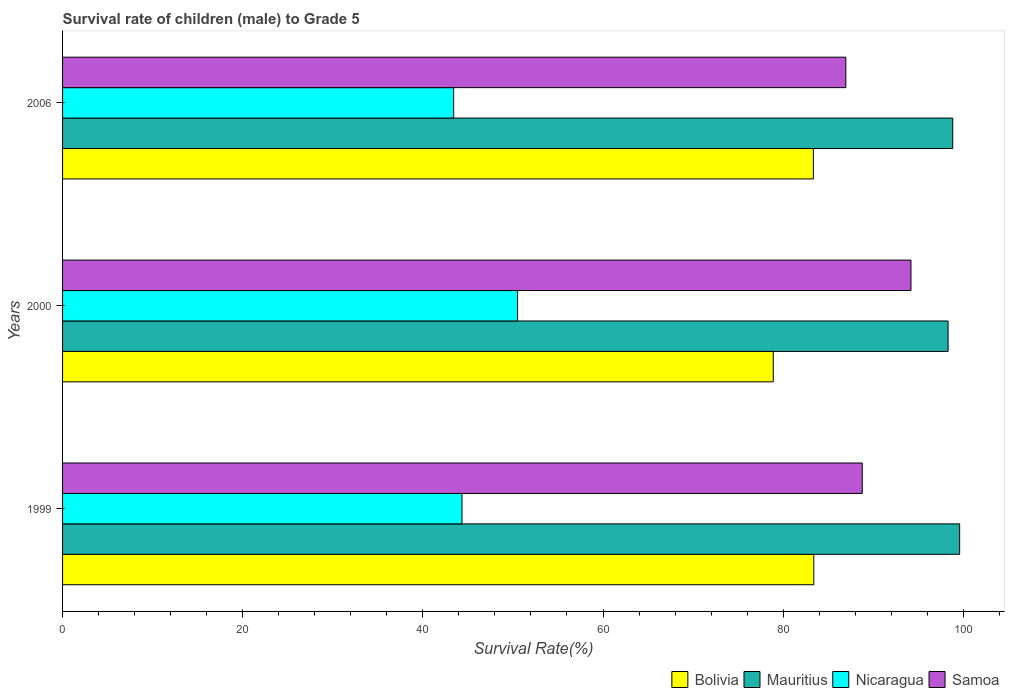How many bars are there on the 1st tick from the top?
Give a very brief answer. 4. In how many cases, is the number of bars for a given year not equal to the number of legend labels?
Provide a short and direct response. 0. What is the survival rate of male children to grade 5 in Samoa in 2006?
Make the answer very short. 86.96. Across all years, what is the maximum survival rate of male children to grade 5 in Samoa?
Your response must be concise. 94.19. Across all years, what is the minimum survival rate of male children to grade 5 in Samoa?
Offer a terse response. 86.96. In which year was the survival rate of male children to grade 5 in Samoa maximum?
Your answer should be very brief. 2000. What is the total survival rate of male children to grade 5 in Mauritius in the graph?
Keep it short and to the point. 296.73. What is the difference between the survival rate of male children to grade 5 in Bolivia in 1999 and that in 2000?
Provide a succinct answer. 4.5. What is the difference between the survival rate of male children to grade 5 in Nicaragua in 2000 and the survival rate of male children to grade 5 in Samoa in 1999?
Your response must be concise. -38.27. What is the average survival rate of male children to grade 5 in Samoa per year?
Ensure brevity in your answer.  89.98. In the year 2000, what is the difference between the survival rate of male children to grade 5 in Nicaragua and survival rate of male children to grade 5 in Samoa?
Give a very brief answer. -43.67. In how many years, is the survival rate of male children to grade 5 in Samoa greater than 28 %?
Your response must be concise. 3. What is the ratio of the survival rate of male children to grade 5 in Mauritius in 1999 to that in 2000?
Ensure brevity in your answer.  1.01. Is the difference between the survival rate of male children to grade 5 in Nicaragua in 2000 and 2006 greater than the difference between the survival rate of male children to grade 5 in Samoa in 2000 and 2006?
Offer a terse response. No. What is the difference between the highest and the second highest survival rate of male children to grade 5 in Samoa?
Provide a succinct answer. 5.41. What is the difference between the highest and the lowest survival rate of male children to grade 5 in Bolivia?
Make the answer very short. 4.5. In how many years, is the survival rate of male children to grade 5 in Nicaragua greater than the average survival rate of male children to grade 5 in Nicaragua taken over all years?
Your answer should be very brief. 1. Is it the case that in every year, the sum of the survival rate of male children to grade 5 in Nicaragua and survival rate of male children to grade 5 in Bolivia is greater than the sum of survival rate of male children to grade 5 in Samoa and survival rate of male children to grade 5 in Mauritius?
Offer a very short reply. No. What does the 4th bar from the top in 1999 represents?
Ensure brevity in your answer.  Bolivia. What does the 4th bar from the bottom in 1999 represents?
Provide a short and direct response. Samoa. Are all the bars in the graph horizontal?
Your answer should be compact. Yes. What is the difference between two consecutive major ticks on the X-axis?
Your answer should be very brief. 20. Does the graph contain any zero values?
Your answer should be compact. No. How are the legend labels stacked?
Make the answer very short. Horizontal. What is the title of the graph?
Offer a terse response. Survival rate of children (male) to Grade 5. What is the label or title of the X-axis?
Offer a terse response. Survival Rate(%). What is the Survival Rate(%) in Bolivia in 1999?
Offer a very short reply. 83.4. What is the Survival Rate(%) of Mauritius in 1999?
Ensure brevity in your answer.  99.59. What is the Survival Rate(%) of Nicaragua in 1999?
Your answer should be very brief. 44.34. What is the Survival Rate(%) of Samoa in 1999?
Give a very brief answer. 88.78. What is the Survival Rate(%) of Bolivia in 2000?
Provide a short and direct response. 78.9. What is the Survival Rate(%) in Mauritius in 2000?
Give a very brief answer. 98.31. What is the Survival Rate(%) in Nicaragua in 2000?
Provide a succinct answer. 50.51. What is the Survival Rate(%) in Samoa in 2000?
Your answer should be compact. 94.19. What is the Survival Rate(%) in Bolivia in 2006?
Offer a terse response. 83.35. What is the Survival Rate(%) in Mauritius in 2006?
Make the answer very short. 98.82. What is the Survival Rate(%) in Nicaragua in 2006?
Keep it short and to the point. 43.42. What is the Survival Rate(%) in Samoa in 2006?
Keep it short and to the point. 86.96. Across all years, what is the maximum Survival Rate(%) of Bolivia?
Your response must be concise. 83.4. Across all years, what is the maximum Survival Rate(%) in Mauritius?
Offer a very short reply. 99.59. Across all years, what is the maximum Survival Rate(%) in Nicaragua?
Offer a very short reply. 50.51. Across all years, what is the maximum Survival Rate(%) of Samoa?
Keep it short and to the point. 94.19. Across all years, what is the minimum Survival Rate(%) in Bolivia?
Provide a short and direct response. 78.9. Across all years, what is the minimum Survival Rate(%) in Mauritius?
Offer a terse response. 98.31. Across all years, what is the minimum Survival Rate(%) of Nicaragua?
Offer a terse response. 43.42. Across all years, what is the minimum Survival Rate(%) of Samoa?
Ensure brevity in your answer.  86.96. What is the total Survival Rate(%) of Bolivia in the graph?
Make the answer very short. 245.66. What is the total Survival Rate(%) in Mauritius in the graph?
Offer a terse response. 296.73. What is the total Survival Rate(%) in Nicaragua in the graph?
Give a very brief answer. 138.28. What is the total Survival Rate(%) of Samoa in the graph?
Your answer should be very brief. 269.93. What is the difference between the Survival Rate(%) in Bolivia in 1999 and that in 2000?
Your answer should be compact. 4.5. What is the difference between the Survival Rate(%) of Mauritius in 1999 and that in 2000?
Provide a succinct answer. 1.28. What is the difference between the Survival Rate(%) of Nicaragua in 1999 and that in 2000?
Offer a terse response. -6.17. What is the difference between the Survival Rate(%) of Samoa in 1999 and that in 2000?
Provide a succinct answer. -5.41. What is the difference between the Survival Rate(%) in Bolivia in 1999 and that in 2006?
Your answer should be compact. 0.05. What is the difference between the Survival Rate(%) of Mauritius in 1999 and that in 2006?
Your answer should be compact. 0.77. What is the difference between the Survival Rate(%) in Nicaragua in 1999 and that in 2006?
Make the answer very short. 0.92. What is the difference between the Survival Rate(%) of Samoa in 1999 and that in 2006?
Offer a very short reply. 1.82. What is the difference between the Survival Rate(%) in Bolivia in 2000 and that in 2006?
Your answer should be very brief. -4.46. What is the difference between the Survival Rate(%) in Mauritius in 2000 and that in 2006?
Your answer should be compact. -0.51. What is the difference between the Survival Rate(%) of Nicaragua in 2000 and that in 2006?
Your answer should be compact. 7.09. What is the difference between the Survival Rate(%) of Samoa in 2000 and that in 2006?
Provide a succinct answer. 7.23. What is the difference between the Survival Rate(%) in Bolivia in 1999 and the Survival Rate(%) in Mauritius in 2000?
Provide a succinct answer. -14.91. What is the difference between the Survival Rate(%) in Bolivia in 1999 and the Survival Rate(%) in Nicaragua in 2000?
Your answer should be compact. 32.89. What is the difference between the Survival Rate(%) of Bolivia in 1999 and the Survival Rate(%) of Samoa in 2000?
Make the answer very short. -10.79. What is the difference between the Survival Rate(%) in Mauritius in 1999 and the Survival Rate(%) in Nicaragua in 2000?
Provide a succinct answer. 49.08. What is the difference between the Survival Rate(%) of Mauritius in 1999 and the Survival Rate(%) of Samoa in 2000?
Your answer should be compact. 5.4. What is the difference between the Survival Rate(%) in Nicaragua in 1999 and the Survival Rate(%) in Samoa in 2000?
Give a very brief answer. -49.85. What is the difference between the Survival Rate(%) of Bolivia in 1999 and the Survival Rate(%) of Mauritius in 2006?
Keep it short and to the point. -15.42. What is the difference between the Survival Rate(%) of Bolivia in 1999 and the Survival Rate(%) of Nicaragua in 2006?
Make the answer very short. 39.98. What is the difference between the Survival Rate(%) in Bolivia in 1999 and the Survival Rate(%) in Samoa in 2006?
Your answer should be very brief. -3.56. What is the difference between the Survival Rate(%) of Mauritius in 1999 and the Survival Rate(%) of Nicaragua in 2006?
Provide a succinct answer. 56.17. What is the difference between the Survival Rate(%) in Mauritius in 1999 and the Survival Rate(%) in Samoa in 2006?
Your answer should be compact. 12.64. What is the difference between the Survival Rate(%) in Nicaragua in 1999 and the Survival Rate(%) in Samoa in 2006?
Your answer should be very brief. -42.62. What is the difference between the Survival Rate(%) in Bolivia in 2000 and the Survival Rate(%) in Mauritius in 2006?
Provide a succinct answer. -19.92. What is the difference between the Survival Rate(%) in Bolivia in 2000 and the Survival Rate(%) in Nicaragua in 2006?
Give a very brief answer. 35.48. What is the difference between the Survival Rate(%) in Bolivia in 2000 and the Survival Rate(%) in Samoa in 2006?
Give a very brief answer. -8.06. What is the difference between the Survival Rate(%) in Mauritius in 2000 and the Survival Rate(%) in Nicaragua in 2006?
Keep it short and to the point. 54.89. What is the difference between the Survival Rate(%) of Mauritius in 2000 and the Survival Rate(%) of Samoa in 2006?
Your answer should be compact. 11.35. What is the difference between the Survival Rate(%) of Nicaragua in 2000 and the Survival Rate(%) of Samoa in 2006?
Offer a terse response. -36.44. What is the average Survival Rate(%) in Bolivia per year?
Provide a short and direct response. 81.89. What is the average Survival Rate(%) of Mauritius per year?
Offer a very short reply. 98.91. What is the average Survival Rate(%) in Nicaragua per year?
Give a very brief answer. 46.09. What is the average Survival Rate(%) in Samoa per year?
Make the answer very short. 89.98. In the year 1999, what is the difference between the Survival Rate(%) in Bolivia and Survival Rate(%) in Mauritius?
Your answer should be very brief. -16.19. In the year 1999, what is the difference between the Survival Rate(%) of Bolivia and Survival Rate(%) of Nicaragua?
Give a very brief answer. 39.06. In the year 1999, what is the difference between the Survival Rate(%) of Bolivia and Survival Rate(%) of Samoa?
Offer a very short reply. -5.38. In the year 1999, what is the difference between the Survival Rate(%) in Mauritius and Survival Rate(%) in Nicaragua?
Give a very brief answer. 55.25. In the year 1999, what is the difference between the Survival Rate(%) of Mauritius and Survival Rate(%) of Samoa?
Your response must be concise. 10.81. In the year 1999, what is the difference between the Survival Rate(%) of Nicaragua and Survival Rate(%) of Samoa?
Offer a terse response. -44.44. In the year 2000, what is the difference between the Survival Rate(%) in Bolivia and Survival Rate(%) in Mauritius?
Your answer should be compact. -19.41. In the year 2000, what is the difference between the Survival Rate(%) in Bolivia and Survival Rate(%) in Nicaragua?
Give a very brief answer. 28.38. In the year 2000, what is the difference between the Survival Rate(%) in Bolivia and Survival Rate(%) in Samoa?
Your answer should be very brief. -15.29. In the year 2000, what is the difference between the Survival Rate(%) of Mauritius and Survival Rate(%) of Nicaragua?
Give a very brief answer. 47.8. In the year 2000, what is the difference between the Survival Rate(%) in Mauritius and Survival Rate(%) in Samoa?
Provide a short and direct response. 4.12. In the year 2000, what is the difference between the Survival Rate(%) in Nicaragua and Survival Rate(%) in Samoa?
Provide a short and direct response. -43.67. In the year 2006, what is the difference between the Survival Rate(%) of Bolivia and Survival Rate(%) of Mauritius?
Give a very brief answer. -15.47. In the year 2006, what is the difference between the Survival Rate(%) in Bolivia and Survival Rate(%) in Nicaragua?
Offer a very short reply. 39.93. In the year 2006, what is the difference between the Survival Rate(%) in Bolivia and Survival Rate(%) in Samoa?
Make the answer very short. -3.6. In the year 2006, what is the difference between the Survival Rate(%) of Mauritius and Survival Rate(%) of Nicaragua?
Keep it short and to the point. 55.4. In the year 2006, what is the difference between the Survival Rate(%) of Mauritius and Survival Rate(%) of Samoa?
Provide a succinct answer. 11.87. In the year 2006, what is the difference between the Survival Rate(%) in Nicaragua and Survival Rate(%) in Samoa?
Your answer should be very brief. -43.54. What is the ratio of the Survival Rate(%) in Bolivia in 1999 to that in 2000?
Your answer should be compact. 1.06. What is the ratio of the Survival Rate(%) in Nicaragua in 1999 to that in 2000?
Keep it short and to the point. 0.88. What is the ratio of the Survival Rate(%) in Samoa in 1999 to that in 2000?
Provide a short and direct response. 0.94. What is the ratio of the Survival Rate(%) of Bolivia in 1999 to that in 2006?
Ensure brevity in your answer.  1. What is the ratio of the Survival Rate(%) in Nicaragua in 1999 to that in 2006?
Provide a succinct answer. 1.02. What is the ratio of the Survival Rate(%) of Bolivia in 2000 to that in 2006?
Your answer should be compact. 0.95. What is the ratio of the Survival Rate(%) in Nicaragua in 2000 to that in 2006?
Your response must be concise. 1.16. What is the ratio of the Survival Rate(%) in Samoa in 2000 to that in 2006?
Offer a very short reply. 1.08. What is the difference between the highest and the second highest Survival Rate(%) in Bolivia?
Ensure brevity in your answer.  0.05. What is the difference between the highest and the second highest Survival Rate(%) in Mauritius?
Offer a terse response. 0.77. What is the difference between the highest and the second highest Survival Rate(%) of Nicaragua?
Your answer should be very brief. 6.17. What is the difference between the highest and the second highest Survival Rate(%) in Samoa?
Make the answer very short. 5.41. What is the difference between the highest and the lowest Survival Rate(%) in Bolivia?
Keep it short and to the point. 4.5. What is the difference between the highest and the lowest Survival Rate(%) of Mauritius?
Ensure brevity in your answer.  1.28. What is the difference between the highest and the lowest Survival Rate(%) of Nicaragua?
Make the answer very short. 7.09. What is the difference between the highest and the lowest Survival Rate(%) of Samoa?
Your answer should be compact. 7.23. 